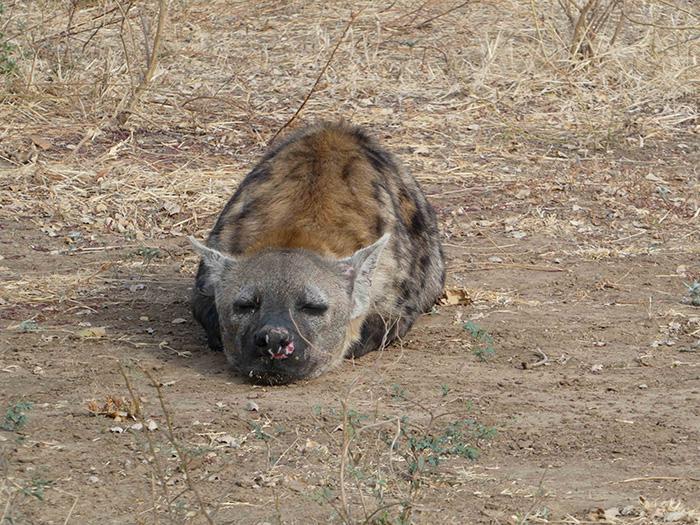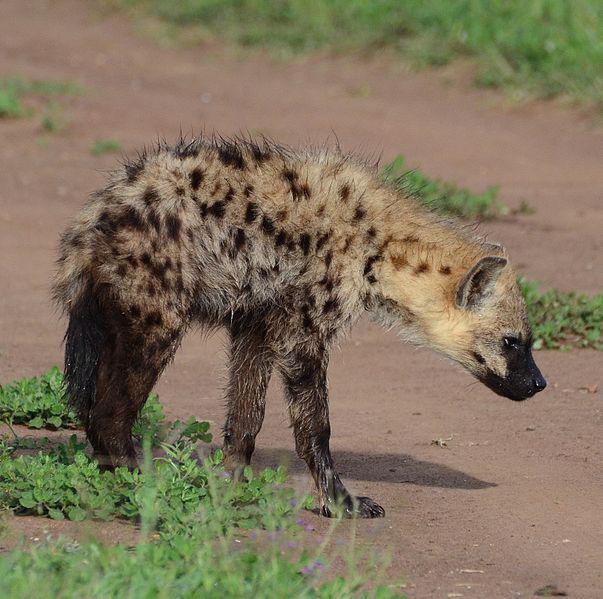The first image is the image on the left, the second image is the image on the right. Given the left and right images, does the statement "Two hyenas are visible." hold true? Answer yes or no. Yes. The first image is the image on the left, the second image is the image on the right. Considering the images on both sides, is "There is at least one hyena laying on the ground." valid? Answer yes or no. Yes. 